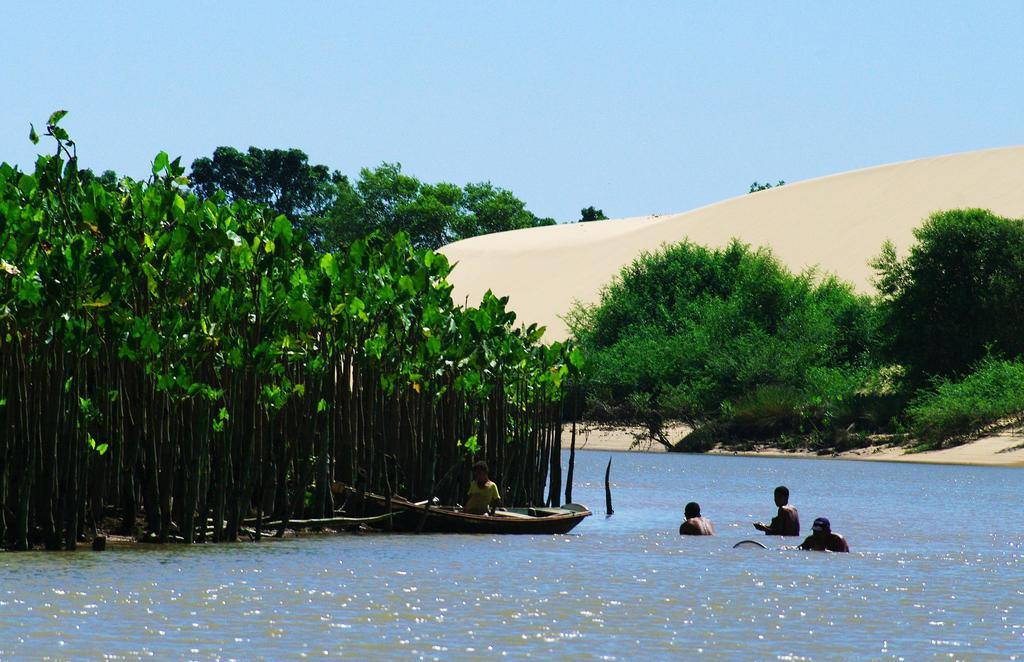What are the people in the image doing? The people in the image are swimming in the water. What else can be seen in the water besides the swimmers? There is a boat floating in the water. What type of vegetation is visible in the image? There are plants visible in the image. What can be seen in the background of the image? There are trees, sand, and a blue sky in the background of the image. What type of jewel can be seen sparkling in the water in the image? There is no jewel visible in the water in the image. What type of voice can be heard coming from the people swimming in the image? There is no indication of any sound or voice in the image, as it is a still photograph. 